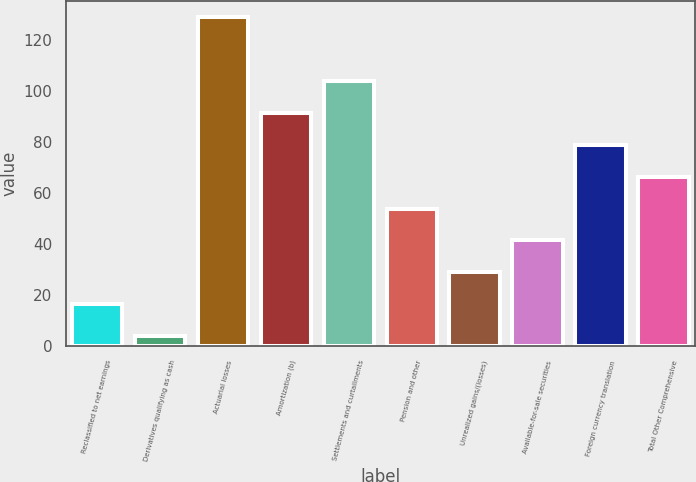<chart> <loc_0><loc_0><loc_500><loc_500><bar_chart><fcel>Reclassified to net earnings<fcel>Derivatives qualifying as cash<fcel>Actuarial losses<fcel>Amortization (b)<fcel>Settlements and curtailments<fcel>Pension and other<fcel>Unrealized gains/(losses)<fcel>Available-for-sale securities<fcel>Foreign currency translation<fcel>Total Other Comprehensive<nl><fcel>16.5<fcel>4<fcel>129<fcel>91.5<fcel>104<fcel>54<fcel>29<fcel>41.5<fcel>79<fcel>66.5<nl></chart> 